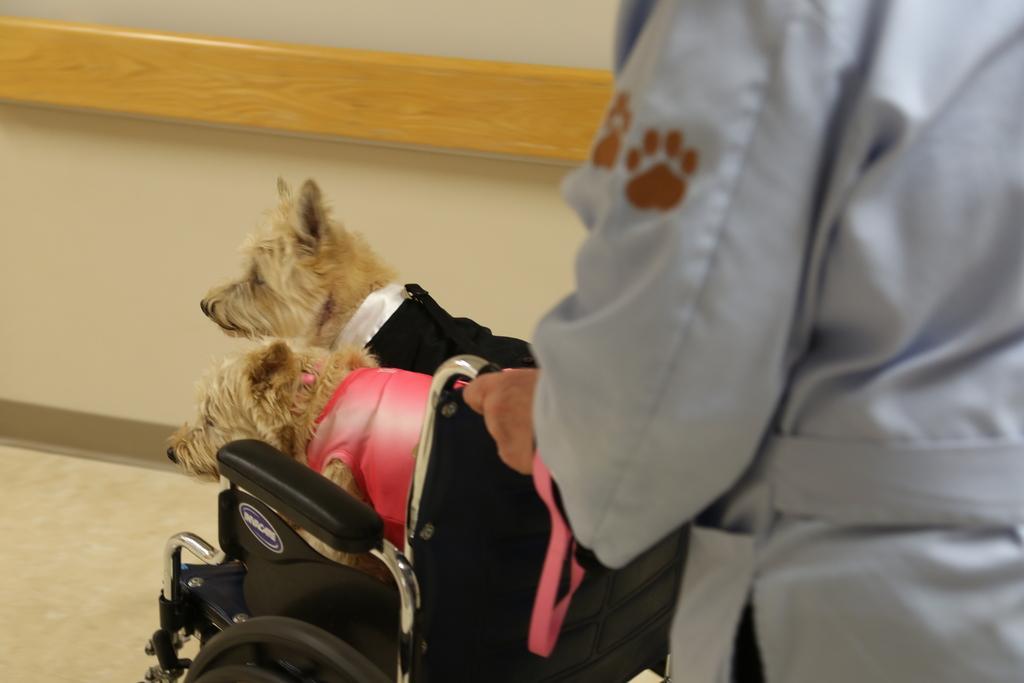How would you summarize this image in a sentence or two? In this picture, we see the two puppies on the wheelchair. On the right side, we see the person is standing and he or she is holding the wheelchair. In the background, we see white wall. At the bottom, we see the white carpet. 